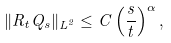<formula> <loc_0><loc_0><loc_500><loc_500>\| R _ { t } Q _ { s } \| _ { L ^ { 2 } } \leq C \left ( \frac { s } { t } \right ) ^ { \alpha } ,</formula> 